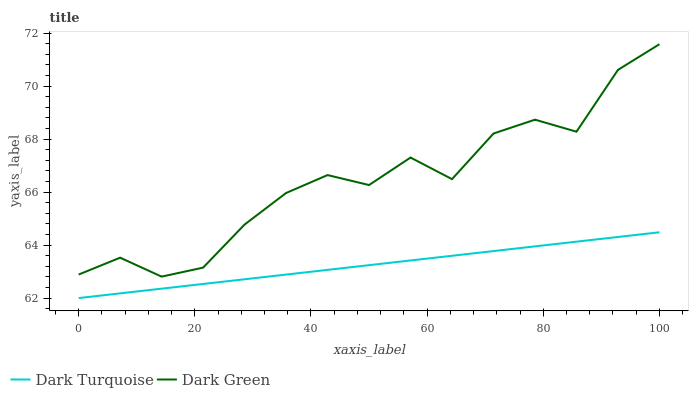Does Dark Green have the minimum area under the curve?
Answer yes or no. No. Is Dark Green the smoothest?
Answer yes or no. No. Does Dark Green have the lowest value?
Answer yes or no. No. Is Dark Turquoise less than Dark Green?
Answer yes or no. Yes. Is Dark Green greater than Dark Turquoise?
Answer yes or no. Yes. Does Dark Turquoise intersect Dark Green?
Answer yes or no. No. 